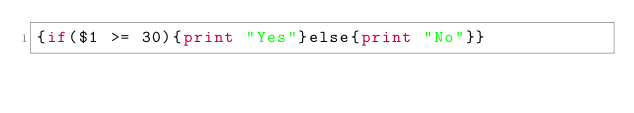Convert code to text. <code><loc_0><loc_0><loc_500><loc_500><_Awk_>{if($1 >= 30){print "Yes"}else{print "No"}}</code> 